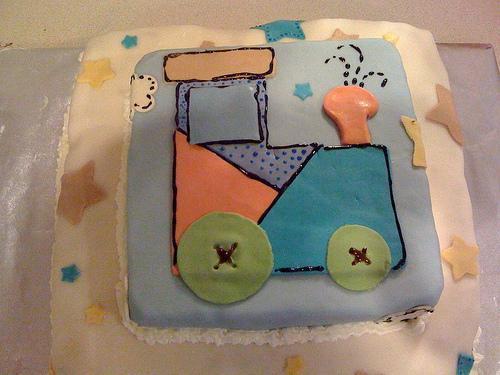How many trains are shown?
Give a very brief answer. 1. 